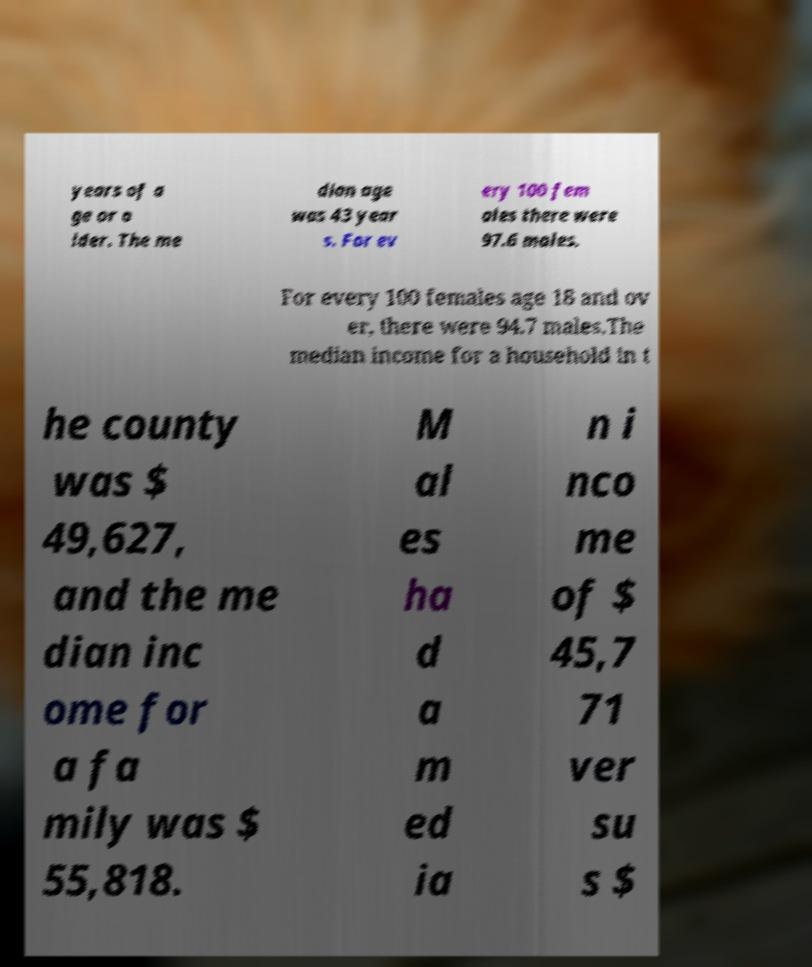I need the written content from this picture converted into text. Can you do that? years of a ge or o lder. The me dian age was 43 year s. For ev ery 100 fem ales there were 97.6 males. For every 100 females age 18 and ov er, there were 94.7 males.The median income for a household in t he county was $ 49,627, and the me dian inc ome for a fa mily was $ 55,818. M al es ha d a m ed ia n i nco me of $ 45,7 71 ver su s $ 